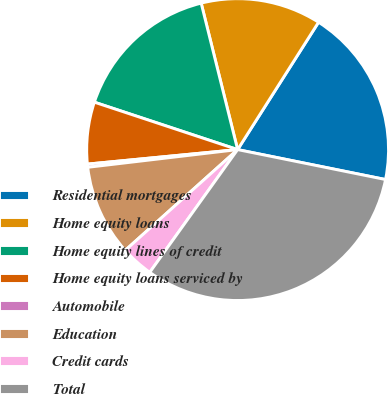<chart> <loc_0><loc_0><loc_500><loc_500><pie_chart><fcel>Residential mortgages<fcel>Home equity loans<fcel>Home equity lines of credit<fcel>Home equity loans serviced by<fcel>Automobile<fcel>Education<fcel>Credit cards<fcel>Total<nl><fcel>19.17%<fcel>12.89%<fcel>16.03%<fcel>6.62%<fcel>0.34%<fcel>9.76%<fcel>3.48%<fcel>31.71%<nl></chart> 